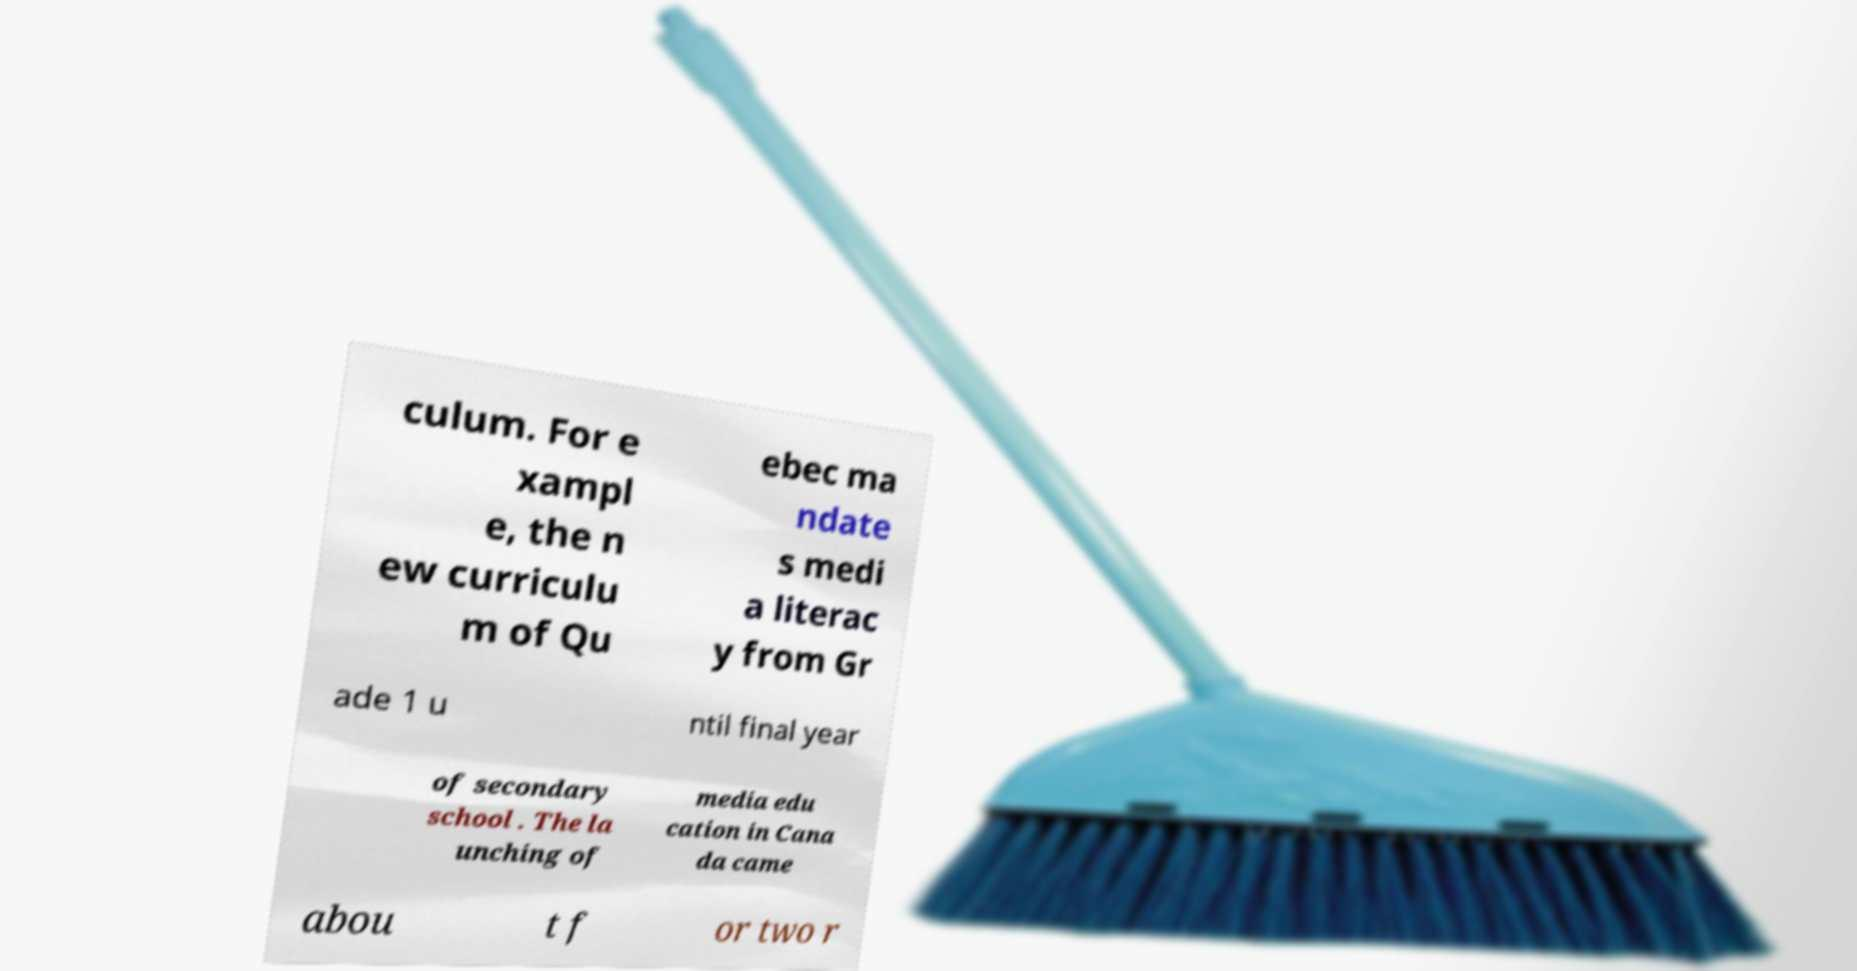Could you assist in decoding the text presented in this image and type it out clearly? culum. For e xampl e, the n ew curriculu m of Qu ebec ma ndate s medi a literac y from Gr ade 1 u ntil final year of secondary school . The la unching of media edu cation in Cana da came abou t f or two r 